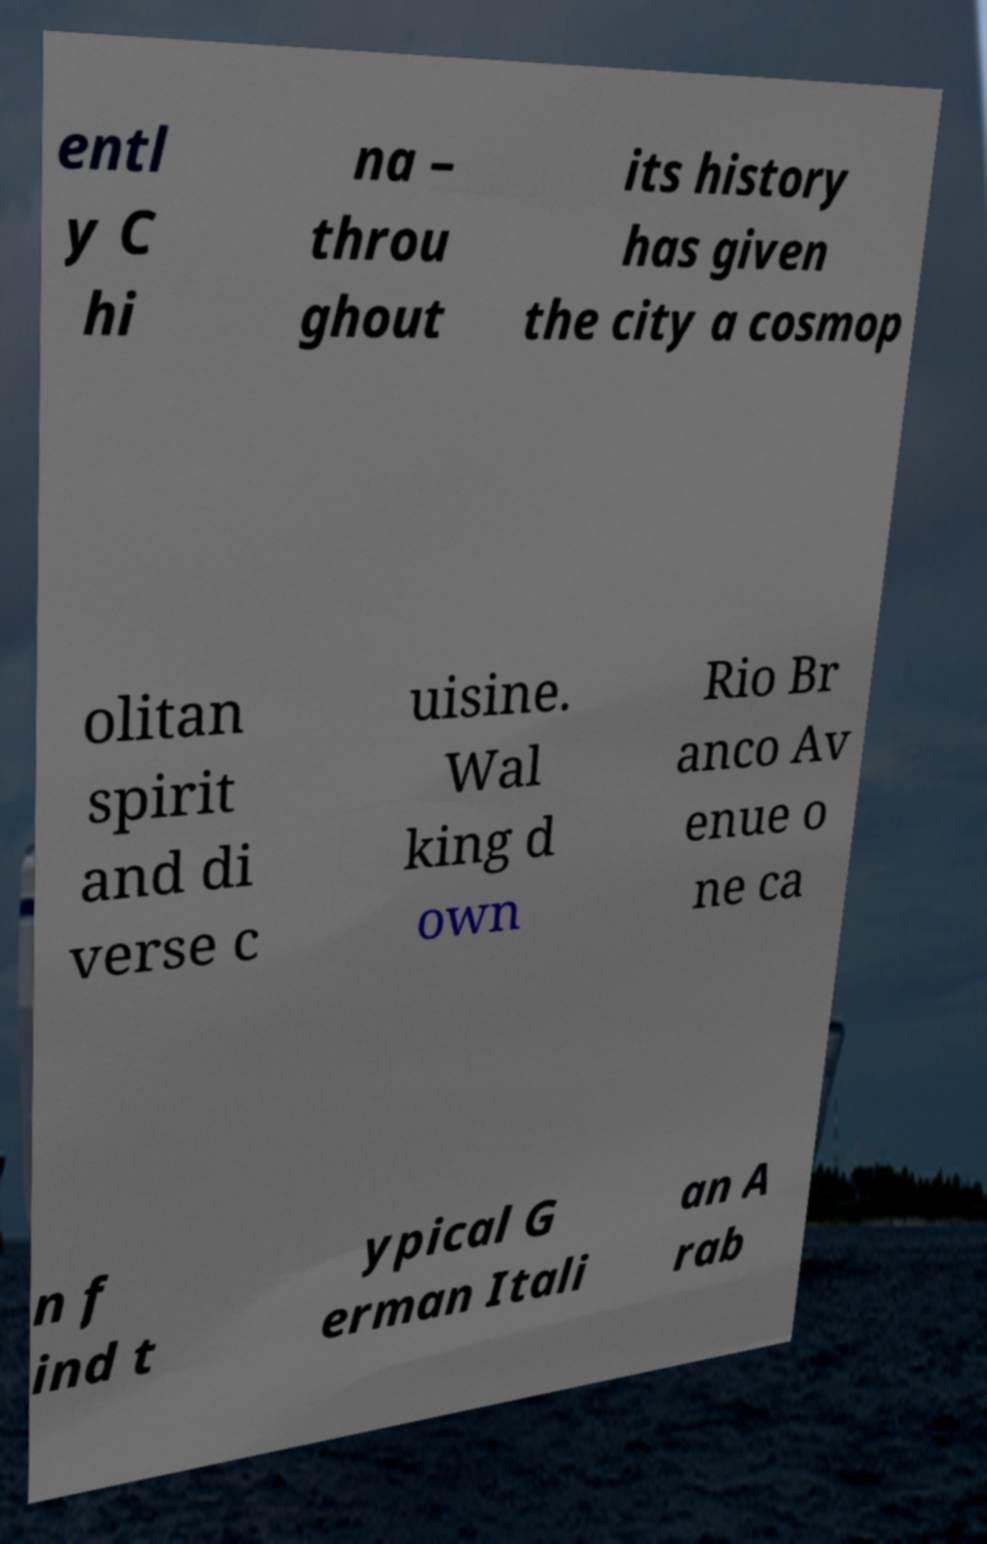Can you read and provide the text displayed in the image?This photo seems to have some interesting text. Can you extract and type it out for me? entl y C hi na – throu ghout its history has given the city a cosmop olitan spirit and di verse c uisine. Wal king d own Rio Br anco Av enue o ne ca n f ind t ypical G erman Itali an A rab 